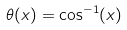<formula> <loc_0><loc_0><loc_500><loc_500>\theta ( x ) = \cos ^ { - 1 } ( x )</formula> 